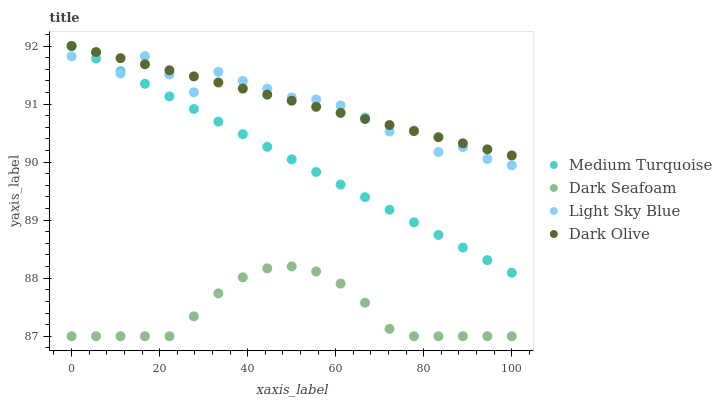Does Dark Seafoam have the minimum area under the curve?
Answer yes or no. Yes. Does Dark Olive have the maximum area under the curve?
Answer yes or no. Yes. Does Light Sky Blue have the minimum area under the curve?
Answer yes or no. No. Does Light Sky Blue have the maximum area under the curve?
Answer yes or no. No. Is Dark Olive the smoothest?
Answer yes or no. Yes. Is Light Sky Blue the roughest?
Answer yes or no. Yes. Is Dark Seafoam the smoothest?
Answer yes or no. No. Is Dark Seafoam the roughest?
Answer yes or no. No. Does Dark Seafoam have the lowest value?
Answer yes or no. Yes. Does Light Sky Blue have the lowest value?
Answer yes or no. No. Does Medium Turquoise have the highest value?
Answer yes or no. Yes. Does Light Sky Blue have the highest value?
Answer yes or no. No. Is Dark Seafoam less than Dark Olive?
Answer yes or no. Yes. Is Medium Turquoise greater than Dark Seafoam?
Answer yes or no. Yes. Does Light Sky Blue intersect Medium Turquoise?
Answer yes or no. Yes. Is Light Sky Blue less than Medium Turquoise?
Answer yes or no. No. Is Light Sky Blue greater than Medium Turquoise?
Answer yes or no. No. Does Dark Seafoam intersect Dark Olive?
Answer yes or no. No. 